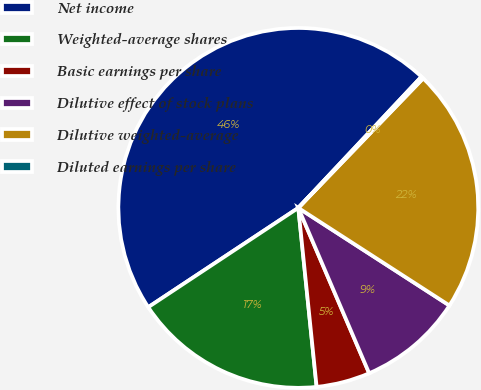Convert chart to OTSL. <chart><loc_0><loc_0><loc_500><loc_500><pie_chart><fcel>Net income<fcel>Weighted-average shares<fcel>Basic earnings per share<fcel>Dilutive effect of stock plans<fcel>Dilutive weighted-average<fcel>Diluted earnings per share<nl><fcel>46.3%<fcel>17.32%<fcel>4.82%<fcel>9.43%<fcel>21.92%<fcel>0.21%<nl></chart> 